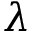Convert formula to latex. <formula><loc_0><loc_0><loc_500><loc_500>\lambda</formula> 